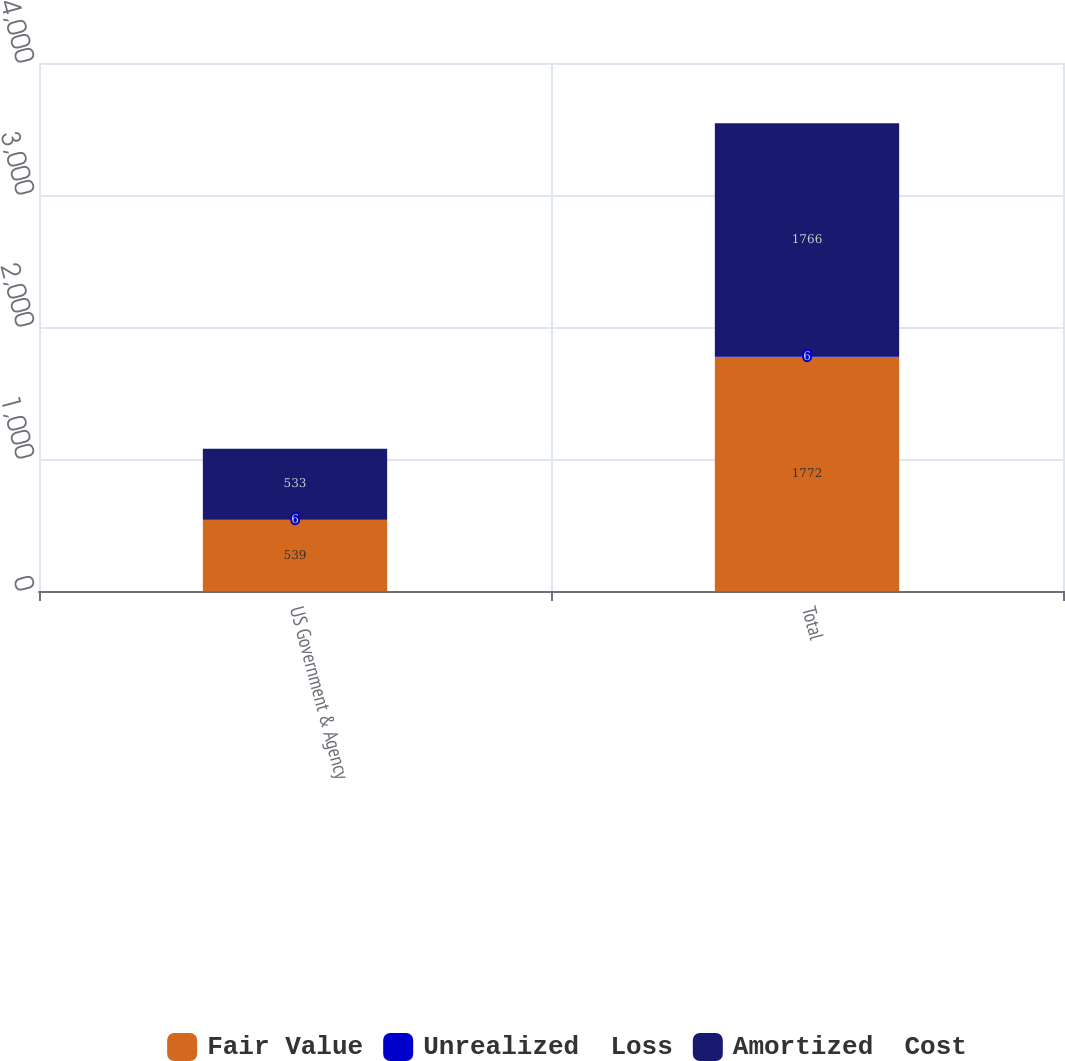<chart> <loc_0><loc_0><loc_500><loc_500><stacked_bar_chart><ecel><fcel>US Government & Agency<fcel>Total<nl><fcel>Fair Value<fcel>539<fcel>1772<nl><fcel>Unrealized  Loss<fcel>6<fcel>6<nl><fcel>Amortized  Cost<fcel>533<fcel>1766<nl></chart> 